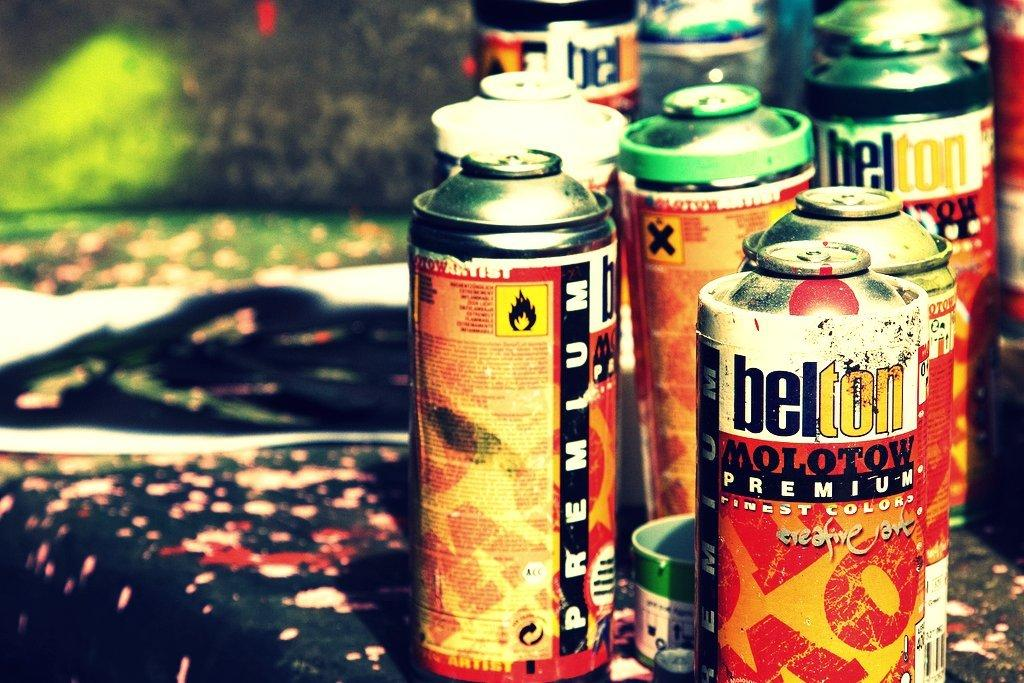<image>
Render a clear and concise summary of the photo. the word Molotow is on the front of the can 